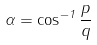<formula> <loc_0><loc_0><loc_500><loc_500>\alpha = \cos ^ { - 1 } { \frac { p } { q } }</formula> 